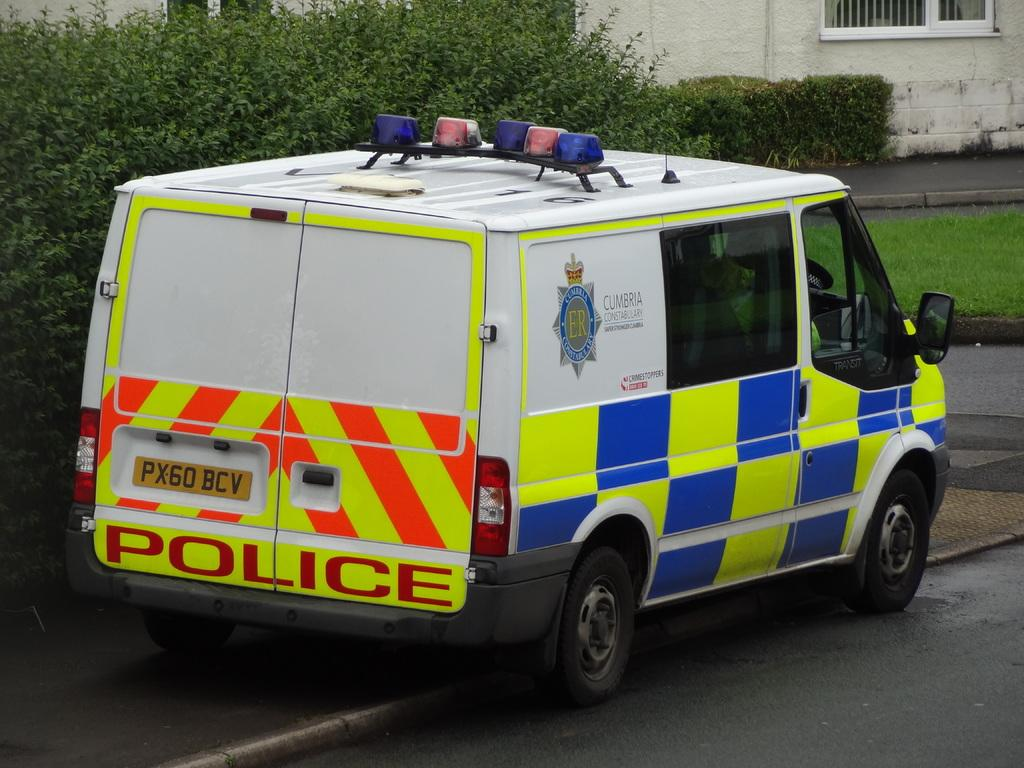<image>
Summarize the visual content of the image. A blue, yellow and white police van is sitting outside of a house. 